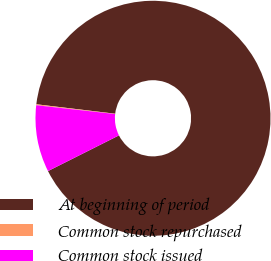Convert chart to OTSL. <chart><loc_0><loc_0><loc_500><loc_500><pie_chart><fcel>At beginning of period<fcel>Common stock repurchased<fcel>Common stock issued<nl><fcel>90.69%<fcel>0.13%<fcel>9.19%<nl></chart> 